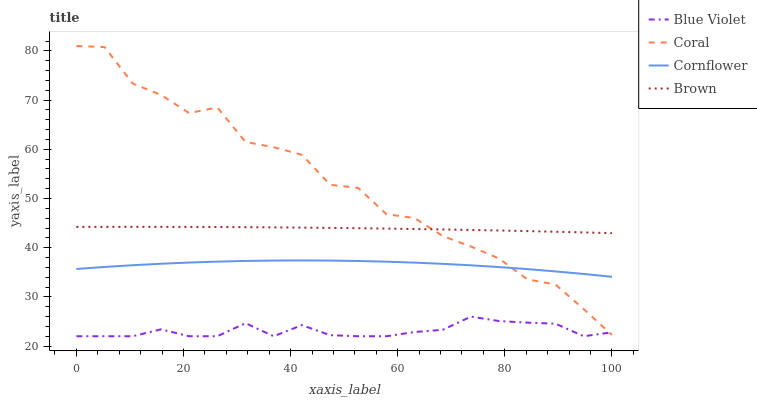Does Blue Violet have the minimum area under the curve?
Answer yes or no. Yes. Does Coral have the maximum area under the curve?
Answer yes or no. Yes. Does Coral have the minimum area under the curve?
Answer yes or no. No. Does Blue Violet have the maximum area under the curve?
Answer yes or no. No. Is Brown the smoothest?
Answer yes or no. Yes. Is Coral the roughest?
Answer yes or no. Yes. Is Blue Violet the smoothest?
Answer yes or no. No. Is Blue Violet the roughest?
Answer yes or no. No. Does Blue Violet have the lowest value?
Answer yes or no. Yes. Does Coral have the lowest value?
Answer yes or no. No. Does Coral have the highest value?
Answer yes or no. Yes. Does Blue Violet have the highest value?
Answer yes or no. No. Is Blue Violet less than Cornflower?
Answer yes or no. Yes. Is Cornflower greater than Blue Violet?
Answer yes or no. Yes. Does Coral intersect Blue Violet?
Answer yes or no. Yes. Is Coral less than Blue Violet?
Answer yes or no. No. Is Coral greater than Blue Violet?
Answer yes or no. No. Does Blue Violet intersect Cornflower?
Answer yes or no. No. 